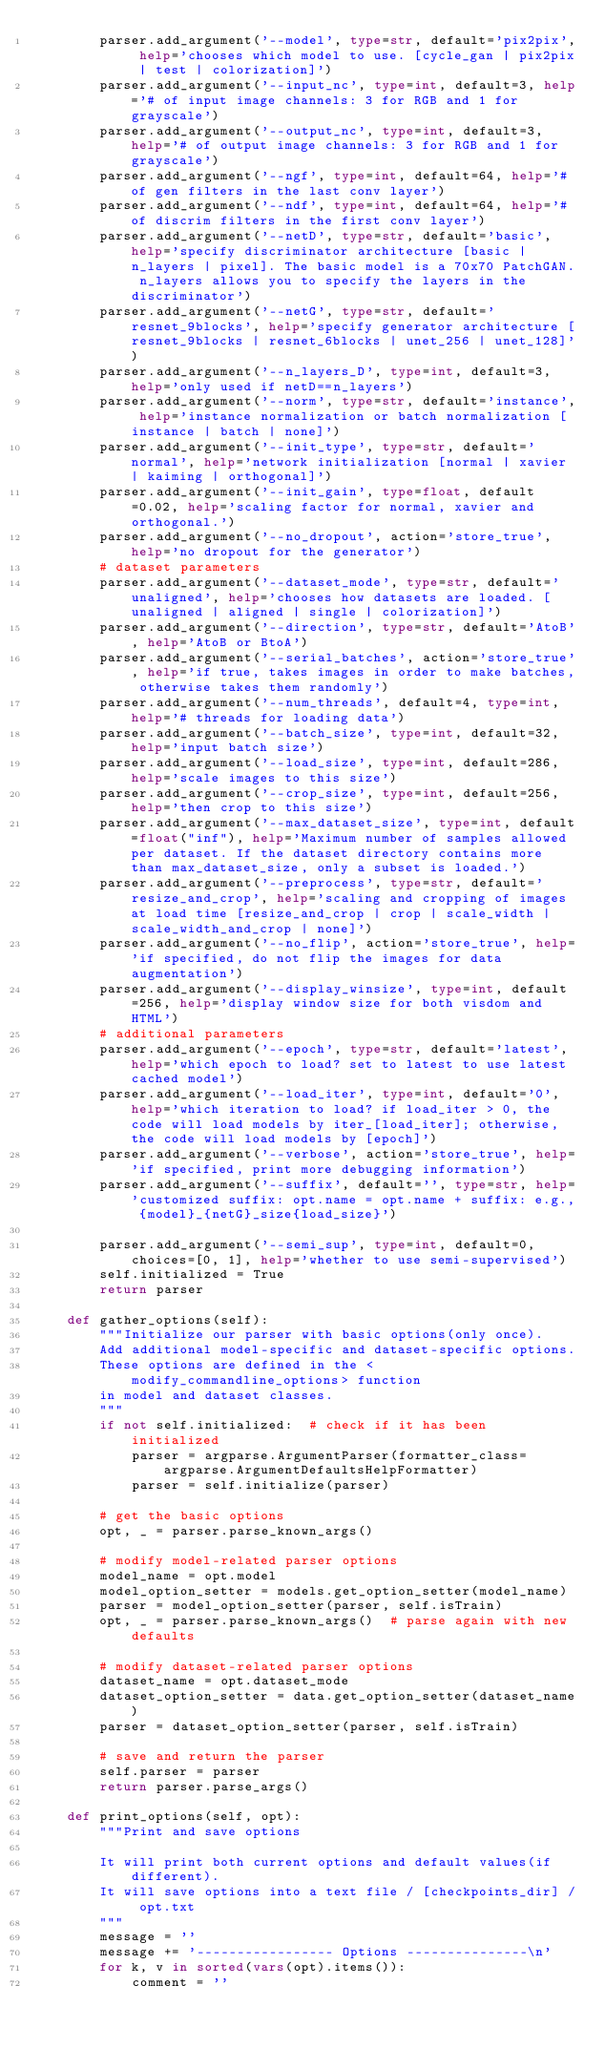Convert code to text. <code><loc_0><loc_0><loc_500><loc_500><_Python_>        parser.add_argument('--model', type=str, default='pix2pix', help='chooses which model to use. [cycle_gan | pix2pix | test | colorization]')
        parser.add_argument('--input_nc', type=int, default=3, help='# of input image channels: 3 for RGB and 1 for grayscale')
        parser.add_argument('--output_nc', type=int, default=3, help='# of output image channels: 3 for RGB and 1 for grayscale')
        parser.add_argument('--ngf', type=int, default=64, help='# of gen filters in the last conv layer')
        parser.add_argument('--ndf', type=int, default=64, help='# of discrim filters in the first conv layer')
        parser.add_argument('--netD', type=str, default='basic', help='specify discriminator architecture [basic | n_layers | pixel]. The basic model is a 70x70 PatchGAN. n_layers allows you to specify the layers in the discriminator')
        parser.add_argument('--netG', type=str, default='resnet_9blocks', help='specify generator architecture [resnet_9blocks | resnet_6blocks | unet_256 | unet_128]')
        parser.add_argument('--n_layers_D', type=int, default=3, help='only used if netD==n_layers')
        parser.add_argument('--norm', type=str, default='instance', help='instance normalization or batch normalization [instance | batch | none]')
        parser.add_argument('--init_type', type=str, default='normal', help='network initialization [normal | xavier | kaiming | orthogonal]')
        parser.add_argument('--init_gain', type=float, default=0.02, help='scaling factor for normal, xavier and orthogonal.')
        parser.add_argument('--no_dropout', action='store_true', help='no dropout for the generator')
        # dataset parameters
        parser.add_argument('--dataset_mode', type=str, default='unaligned', help='chooses how datasets are loaded. [unaligned | aligned | single | colorization]')
        parser.add_argument('--direction', type=str, default='AtoB', help='AtoB or BtoA')
        parser.add_argument('--serial_batches', action='store_true', help='if true, takes images in order to make batches, otherwise takes them randomly')
        parser.add_argument('--num_threads', default=4, type=int, help='# threads for loading data')
        parser.add_argument('--batch_size', type=int, default=32, help='input batch size')
        parser.add_argument('--load_size', type=int, default=286, help='scale images to this size')
        parser.add_argument('--crop_size', type=int, default=256, help='then crop to this size')
        parser.add_argument('--max_dataset_size', type=int, default=float("inf"), help='Maximum number of samples allowed per dataset. If the dataset directory contains more than max_dataset_size, only a subset is loaded.')
        parser.add_argument('--preprocess', type=str, default='resize_and_crop', help='scaling and cropping of images at load time [resize_and_crop | crop | scale_width | scale_width_and_crop | none]')
        parser.add_argument('--no_flip', action='store_true', help='if specified, do not flip the images for data augmentation')
        parser.add_argument('--display_winsize', type=int, default=256, help='display window size for both visdom and HTML')
        # additional parameters
        parser.add_argument('--epoch', type=str, default='latest', help='which epoch to load? set to latest to use latest cached model')
        parser.add_argument('--load_iter', type=int, default='0', help='which iteration to load? if load_iter > 0, the code will load models by iter_[load_iter]; otherwise, the code will load models by [epoch]')
        parser.add_argument('--verbose', action='store_true', help='if specified, print more debugging information')
        parser.add_argument('--suffix', default='', type=str, help='customized suffix: opt.name = opt.name + suffix: e.g., {model}_{netG}_size{load_size}')

        parser.add_argument('--semi_sup', type=int, default=0, choices=[0, 1], help='whether to use semi-supervised')
        self.initialized = True
        return parser

    def gather_options(self):
        """Initialize our parser with basic options(only once).
        Add additional model-specific and dataset-specific options.
        These options are defined in the <modify_commandline_options> function
        in model and dataset classes.
        """
        if not self.initialized:  # check if it has been initialized
            parser = argparse.ArgumentParser(formatter_class=argparse.ArgumentDefaultsHelpFormatter)
            parser = self.initialize(parser)

        # get the basic options
        opt, _ = parser.parse_known_args()

        # modify model-related parser options
        model_name = opt.model
        model_option_setter = models.get_option_setter(model_name)
        parser = model_option_setter(parser, self.isTrain)
        opt, _ = parser.parse_known_args()  # parse again with new defaults

        # modify dataset-related parser options
        dataset_name = opt.dataset_mode
        dataset_option_setter = data.get_option_setter(dataset_name)
        parser = dataset_option_setter(parser, self.isTrain)

        # save and return the parser
        self.parser = parser
        return parser.parse_args()

    def print_options(self, opt):
        """Print and save options

        It will print both current options and default values(if different).
        It will save options into a text file / [checkpoints_dir] / opt.txt
        """
        message = ''
        message += '----------------- Options ---------------\n'
        for k, v in sorted(vars(opt).items()):
            comment = ''</code> 